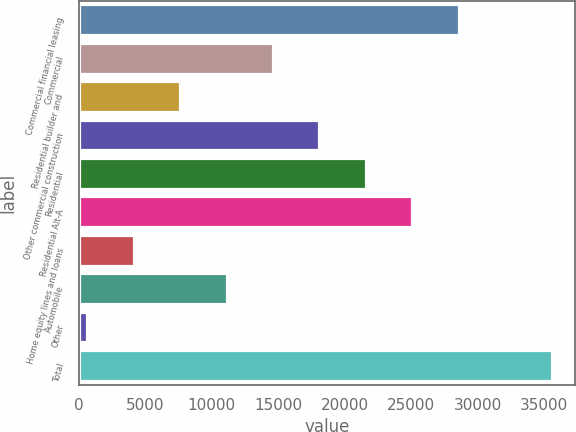Convert chart to OTSL. <chart><loc_0><loc_0><loc_500><loc_500><bar_chart><fcel>Commercial financial leasing<fcel>Commercial<fcel>Residential builder and<fcel>Other commercial construction<fcel>Residential<fcel>Residential Alt-A<fcel>Home equity lines and loans<fcel>Automobile<fcel>Other<fcel>Total<nl><fcel>28574.8<fcel>14604.4<fcel>7619.2<fcel>18097<fcel>21589.6<fcel>25082.2<fcel>4126.6<fcel>11111.8<fcel>634<fcel>35560<nl></chart> 